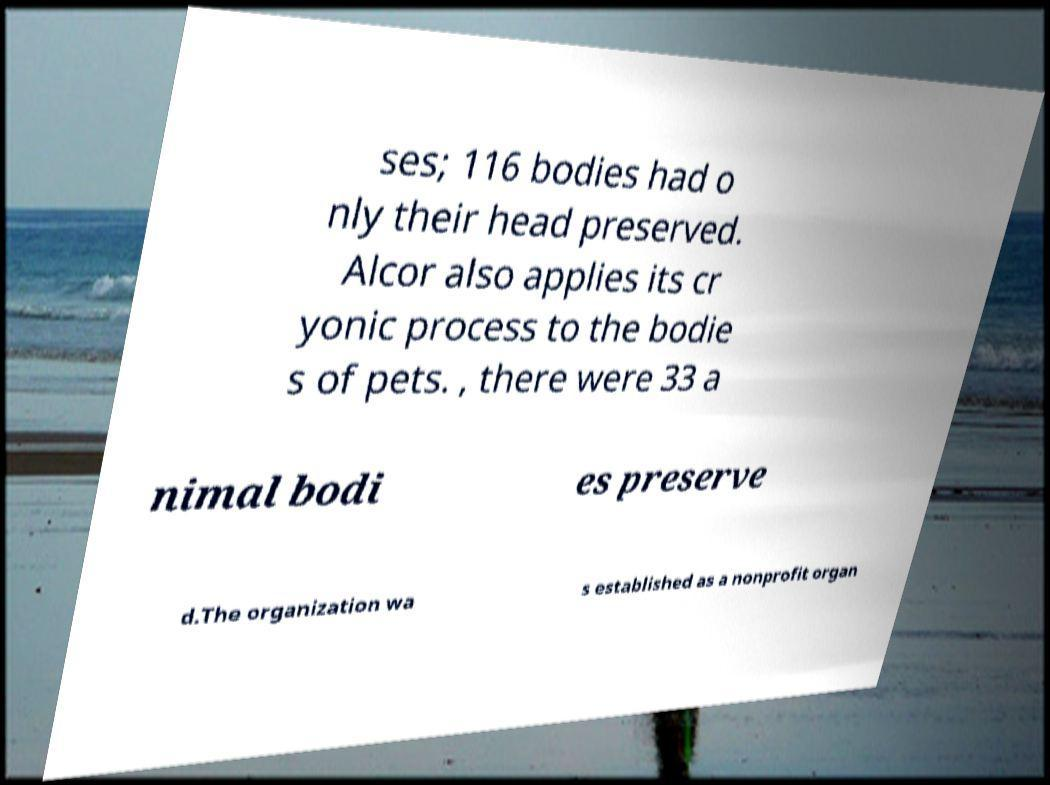What messages or text are displayed in this image? I need them in a readable, typed format. ses; 116 bodies had o nly their head preserved. Alcor also applies its cr yonic process to the bodie s of pets. , there were 33 a nimal bodi es preserve d.The organization wa s established as a nonprofit organ 